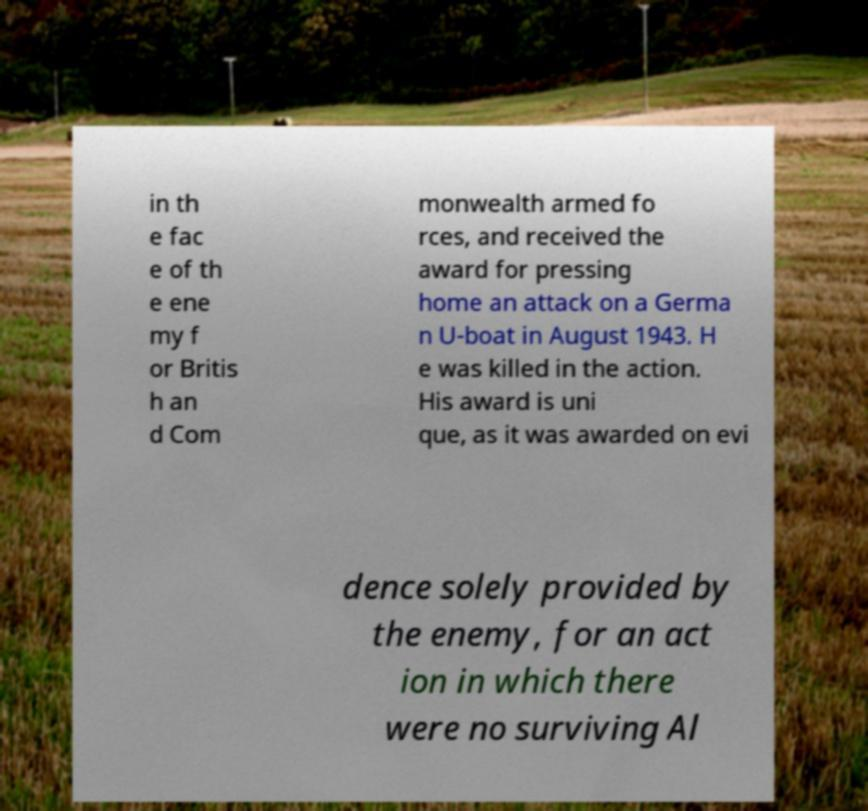Can you accurately transcribe the text from the provided image for me? in th e fac e of th e ene my f or Britis h an d Com monwealth armed fo rces, and received the award for pressing home an attack on a Germa n U-boat in August 1943. H e was killed in the action. His award is uni que, as it was awarded on evi dence solely provided by the enemy, for an act ion in which there were no surviving Al 